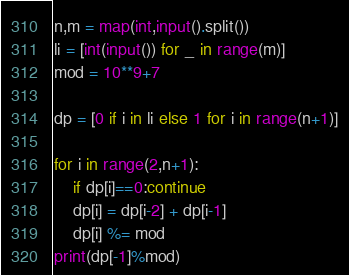<code> <loc_0><loc_0><loc_500><loc_500><_Python_>n,m = map(int,input().split())
li = [int(input()) for _ in range(m)]
mod = 10**9+7

dp = [0 if i in li else 1 for i in range(n+1)]

for i in range(2,n+1):
    if dp[i]==0:continue
    dp[i] = dp[i-2] + dp[i-1]
    dp[i] %= mod
print(dp[-1]%mod)</code> 